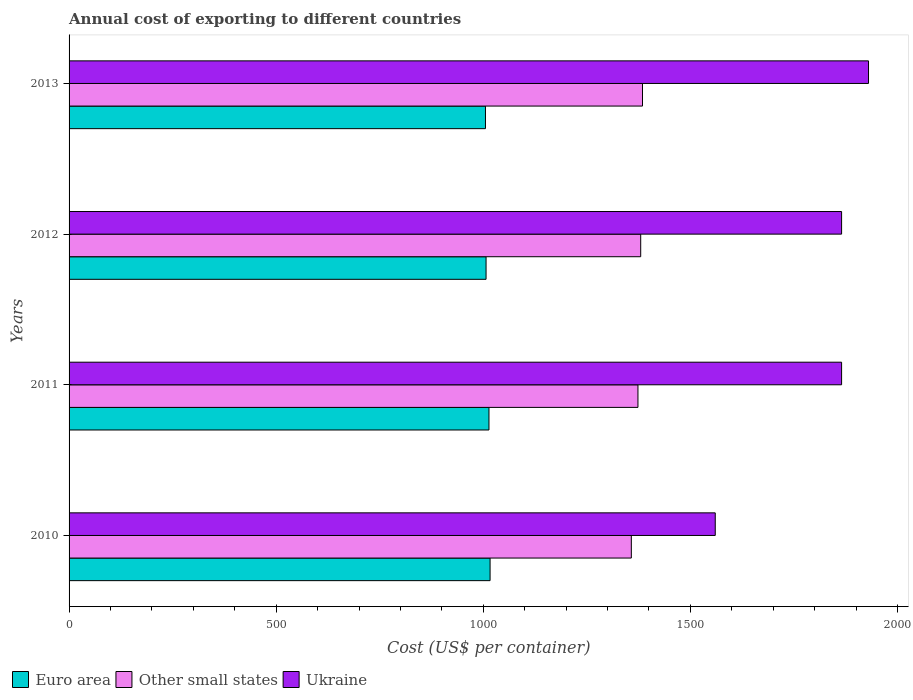How many groups of bars are there?
Ensure brevity in your answer.  4. Are the number of bars per tick equal to the number of legend labels?
Keep it short and to the point. Yes. How many bars are there on the 1st tick from the bottom?
Provide a short and direct response. 3. What is the total annual cost of exporting in Ukraine in 2012?
Offer a terse response. 1865. Across all years, what is the maximum total annual cost of exporting in Other small states?
Provide a short and direct response. 1384.33. Across all years, what is the minimum total annual cost of exporting in Other small states?
Offer a very short reply. 1357.39. What is the total total annual cost of exporting in Other small states in the graph?
Give a very brief answer. 5495.11. What is the difference between the total annual cost of exporting in Other small states in 2010 and that in 2013?
Provide a short and direct response. -26.94. What is the difference between the total annual cost of exporting in Other small states in 2010 and the total annual cost of exporting in Ukraine in 2011?
Your answer should be very brief. -507.61. What is the average total annual cost of exporting in Other small states per year?
Make the answer very short. 1373.78. In the year 2013, what is the difference between the total annual cost of exporting in Euro area and total annual cost of exporting in Ukraine?
Give a very brief answer. -924.74. What is the ratio of the total annual cost of exporting in Euro area in 2012 to that in 2013?
Provide a short and direct response. 1. Is the total annual cost of exporting in Other small states in 2010 less than that in 2011?
Provide a short and direct response. Yes. What is the difference between the highest and the second highest total annual cost of exporting in Euro area?
Your answer should be compact. 2.7. What is the difference between the highest and the lowest total annual cost of exporting in Other small states?
Keep it short and to the point. 26.94. In how many years, is the total annual cost of exporting in Euro area greater than the average total annual cost of exporting in Euro area taken over all years?
Keep it short and to the point. 2. Is the sum of the total annual cost of exporting in Other small states in 2011 and 2013 greater than the maximum total annual cost of exporting in Euro area across all years?
Make the answer very short. Yes. What does the 3rd bar from the top in 2013 represents?
Provide a succinct answer. Euro area. How many bars are there?
Your answer should be compact. 12. Are all the bars in the graph horizontal?
Provide a short and direct response. Yes. What is the difference between two consecutive major ticks on the X-axis?
Your answer should be very brief. 500. Are the values on the major ticks of X-axis written in scientific E-notation?
Offer a terse response. No. Does the graph contain any zero values?
Keep it short and to the point. No. Where does the legend appear in the graph?
Make the answer very short. Bottom left. How many legend labels are there?
Offer a very short reply. 3. What is the title of the graph?
Your response must be concise. Annual cost of exporting to different countries. Does "Bosnia and Herzegovina" appear as one of the legend labels in the graph?
Offer a very short reply. No. What is the label or title of the X-axis?
Your answer should be compact. Cost (US$ per container). What is the Cost (US$ per container) in Euro area in 2010?
Provide a succinct answer. 1016.39. What is the Cost (US$ per container) in Other small states in 2010?
Offer a terse response. 1357.39. What is the Cost (US$ per container) in Ukraine in 2010?
Ensure brevity in your answer.  1560. What is the Cost (US$ per container) in Euro area in 2011?
Your answer should be compact. 1013.68. What is the Cost (US$ per container) in Other small states in 2011?
Ensure brevity in your answer.  1373.39. What is the Cost (US$ per container) in Ukraine in 2011?
Provide a short and direct response. 1865. What is the Cost (US$ per container) of Euro area in 2012?
Offer a very short reply. 1006.68. What is the Cost (US$ per container) in Other small states in 2012?
Provide a succinct answer. 1380. What is the Cost (US$ per container) in Ukraine in 2012?
Your response must be concise. 1865. What is the Cost (US$ per container) of Euro area in 2013?
Keep it short and to the point. 1005.26. What is the Cost (US$ per container) of Other small states in 2013?
Make the answer very short. 1384.33. What is the Cost (US$ per container) of Ukraine in 2013?
Offer a terse response. 1930. Across all years, what is the maximum Cost (US$ per container) of Euro area?
Your answer should be very brief. 1016.39. Across all years, what is the maximum Cost (US$ per container) of Other small states?
Your answer should be very brief. 1384.33. Across all years, what is the maximum Cost (US$ per container) of Ukraine?
Your answer should be compact. 1930. Across all years, what is the minimum Cost (US$ per container) in Euro area?
Keep it short and to the point. 1005.26. Across all years, what is the minimum Cost (US$ per container) in Other small states?
Ensure brevity in your answer.  1357.39. Across all years, what is the minimum Cost (US$ per container) in Ukraine?
Your answer should be compact. 1560. What is the total Cost (US$ per container) of Euro area in the graph?
Your response must be concise. 4042.02. What is the total Cost (US$ per container) in Other small states in the graph?
Offer a very short reply. 5495.11. What is the total Cost (US$ per container) in Ukraine in the graph?
Offer a very short reply. 7220. What is the difference between the Cost (US$ per container) of Euro area in 2010 and that in 2011?
Offer a terse response. 2.7. What is the difference between the Cost (US$ per container) in Other small states in 2010 and that in 2011?
Give a very brief answer. -16. What is the difference between the Cost (US$ per container) of Ukraine in 2010 and that in 2011?
Ensure brevity in your answer.  -305. What is the difference between the Cost (US$ per container) of Euro area in 2010 and that in 2012?
Your answer should be very brief. 9.7. What is the difference between the Cost (US$ per container) in Other small states in 2010 and that in 2012?
Your answer should be very brief. -22.61. What is the difference between the Cost (US$ per container) of Ukraine in 2010 and that in 2012?
Ensure brevity in your answer.  -305. What is the difference between the Cost (US$ per container) in Euro area in 2010 and that in 2013?
Offer a terse response. 11.13. What is the difference between the Cost (US$ per container) in Other small states in 2010 and that in 2013?
Your answer should be very brief. -26.94. What is the difference between the Cost (US$ per container) in Ukraine in 2010 and that in 2013?
Make the answer very short. -370. What is the difference between the Cost (US$ per container) in Other small states in 2011 and that in 2012?
Give a very brief answer. -6.61. What is the difference between the Cost (US$ per container) of Euro area in 2011 and that in 2013?
Provide a succinct answer. 8.42. What is the difference between the Cost (US$ per container) of Other small states in 2011 and that in 2013?
Ensure brevity in your answer.  -10.94. What is the difference between the Cost (US$ per container) in Ukraine in 2011 and that in 2013?
Give a very brief answer. -65. What is the difference between the Cost (US$ per container) of Euro area in 2012 and that in 2013?
Your answer should be compact. 1.42. What is the difference between the Cost (US$ per container) of Other small states in 2012 and that in 2013?
Offer a very short reply. -4.33. What is the difference between the Cost (US$ per container) in Ukraine in 2012 and that in 2013?
Offer a terse response. -65. What is the difference between the Cost (US$ per container) in Euro area in 2010 and the Cost (US$ per container) in Other small states in 2011?
Ensure brevity in your answer.  -357. What is the difference between the Cost (US$ per container) of Euro area in 2010 and the Cost (US$ per container) of Ukraine in 2011?
Provide a short and direct response. -848.61. What is the difference between the Cost (US$ per container) in Other small states in 2010 and the Cost (US$ per container) in Ukraine in 2011?
Keep it short and to the point. -507.61. What is the difference between the Cost (US$ per container) of Euro area in 2010 and the Cost (US$ per container) of Other small states in 2012?
Your answer should be compact. -363.61. What is the difference between the Cost (US$ per container) in Euro area in 2010 and the Cost (US$ per container) in Ukraine in 2012?
Your answer should be very brief. -848.61. What is the difference between the Cost (US$ per container) in Other small states in 2010 and the Cost (US$ per container) in Ukraine in 2012?
Offer a terse response. -507.61. What is the difference between the Cost (US$ per container) in Euro area in 2010 and the Cost (US$ per container) in Other small states in 2013?
Your answer should be compact. -367.94. What is the difference between the Cost (US$ per container) in Euro area in 2010 and the Cost (US$ per container) in Ukraine in 2013?
Your response must be concise. -913.61. What is the difference between the Cost (US$ per container) of Other small states in 2010 and the Cost (US$ per container) of Ukraine in 2013?
Offer a very short reply. -572.61. What is the difference between the Cost (US$ per container) in Euro area in 2011 and the Cost (US$ per container) in Other small states in 2012?
Ensure brevity in your answer.  -366.32. What is the difference between the Cost (US$ per container) of Euro area in 2011 and the Cost (US$ per container) of Ukraine in 2012?
Provide a succinct answer. -851.32. What is the difference between the Cost (US$ per container) in Other small states in 2011 and the Cost (US$ per container) in Ukraine in 2012?
Provide a succinct answer. -491.61. What is the difference between the Cost (US$ per container) in Euro area in 2011 and the Cost (US$ per container) in Other small states in 2013?
Offer a very short reply. -370.65. What is the difference between the Cost (US$ per container) of Euro area in 2011 and the Cost (US$ per container) of Ukraine in 2013?
Ensure brevity in your answer.  -916.32. What is the difference between the Cost (US$ per container) in Other small states in 2011 and the Cost (US$ per container) in Ukraine in 2013?
Provide a short and direct response. -556.61. What is the difference between the Cost (US$ per container) of Euro area in 2012 and the Cost (US$ per container) of Other small states in 2013?
Provide a short and direct response. -377.65. What is the difference between the Cost (US$ per container) in Euro area in 2012 and the Cost (US$ per container) in Ukraine in 2013?
Provide a short and direct response. -923.32. What is the difference between the Cost (US$ per container) in Other small states in 2012 and the Cost (US$ per container) in Ukraine in 2013?
Provide a succinct answer. -550. What is the average Cost (US$ per container) of Euro area per year?
Provide a short and direct response. 1010.51. What is the average Cost (US$ per container) of Other small states per year?
Make the answer very short. 1373.78. What is the average Cost (US$ per container) in Ukraine per year?
Provide a short and direct response. 1805. In the year 2010, what is the difference between the Cost (US$ per container) of Euro area and Cost (US$ per container) of Other small states?
Give a very brief answer. -341. In the year 2010, what is the difference between the Cost (US$ per container) of Euro area and Cost (US$ per container) of Ukraine?
Provide a short and direct response. -543.61. In the year 2010, what is the difference between the Cost (US$ per container) in Other small states and Cost (US$ per container) in Ukraine?
Offer a terse response. -202.61. In the year 2011, what is the difference between the Cost (US$ per container) in Euro area and Cost (US$ per container) in Other small states?
Your answer should be compact. -359.7. In the year 2011, what is the difference between the Cost (US$ per container) in Euro area and Cost (US$ per container) in Ukraine?
Provide a short and direct response. -851.32. In the year 2011, what is the difference between the Cost (US$ per container) in Other small states and Cost (US$ per container) in Ukraine?
Give a very brief answer. -491.61. In the year 2012, what is the difference between the Cost (US$ per container) of Euro area and Cost (US$ per container) of Other small states?
Ensure brevity in your answer.  -373.32. In the year 2012, what is the difference between the Cost (US$ per container) of Euro area and Cost (US$ per container) of Ukraine?
Your answer should be very brief. -858.32. In the year 2012, what is the difference between the Cost (US$ per container) in Other small states and Cost (US$ per container) in Ukraine?
Your answer should be very brief. -485. In the year 2013, what is the difference between the Cost (US$ per container) in Euro area and Cost (US$ per container) in Other small states?
Your answer should be very brief. -379.07. In the year 2013, what is the difference between the Cost (US$ per container) of Euro area and Cost (US$ per container) of Ukraine?
Provide a succinct answer. -924.74. In the year 2013, what is the difference between the Cost (US$ per container) in Other small states and Cost (US$ per container) in Ukraine?
Offer a terse response. -545.67. What is the ratio of the Cost (US$ per container) in Other small states in 2010 to that in 2011?
Provide a short and direct response. 0.99. What is the ratio of the Cost (US$ per container) of Ukraine in 2010 to that in 2011?
Keep it short and to the point. 0.84. What is the ratio of the Cost (US$ per container) of Euro area in 2010 to that in 2012?
Keep it short and to the point. 1.01. What is the ratio of the Cost (US$ per container) in Other small states in 2010 to that in 2012?
Your answer should be very brief. 0.98. What is the ratio of the Cost (US$ per container) in Ukraine in 2010 to that in 2012?
Keep it short and to the point. 0.84. What is the ratio of the Cost (US$ per container) of Euro area in 2010 to that in 2013?
Your response must be concise. 1.01. What is the ratio of the Cost (US$ per container) in Other small states in 2010 to that in 2013?
Offer a terse response. 0.98. What is the ratio of the Cost (US$ per container) in Ukraine in 2010 to that in 2013?
Your answer should be compact. 0.81. What is the ratio of the Cost (US$ per container) of Euro area in 2011 to that in 2012?
Offer a very short reply. 1.01. What is the ratio of the Cost (US$ per container) of Euro area in 2011 to that in 2013?
Provide a short and direct response. 1.01. What is the ratio of the Cost (US$ per container) of Other small states in 2011 to that in 2013?
Your answer should be very brief. 0.99. What is the ratio of the Cost (US$ per container) in Ukraine in 2011 to that in 2013?
Keep it short and to the point. 0.97. What is the ratio of the Cost (US$ per container) of Euro area in 2012 to that in 2013?
Your response must be concise. 1. What is the ratio of the Cost (US$ per container) of Other small states in 2012 to that in 2013?
Your response must be concise. 1. What is the ratio of the Cost (US$ per container) of Ukraine in 2012 to that in 2013?
Your answer should be compact. 0.97. What is the difference between the highest and the second highest Cost (US$ per container) in Euro area?
Offer a very short reply. 2.7. What is the difference between the highest and the second highest Cost (US$ per container) in Other small states?
Offer a very short reply. 4.33. What is the difference between the highest and the lowest Cost (US$ per container) in Euro area?
Keep it short and to the point. 11.13. What is the difference between the highest and the lowest Cost (US$ per container) in Other small states?
Make the answer very short. 26.94. What is the difference between the highest and the lowest Cost (US$ per container) in Ukraine?
Your response must be concise. 370. 